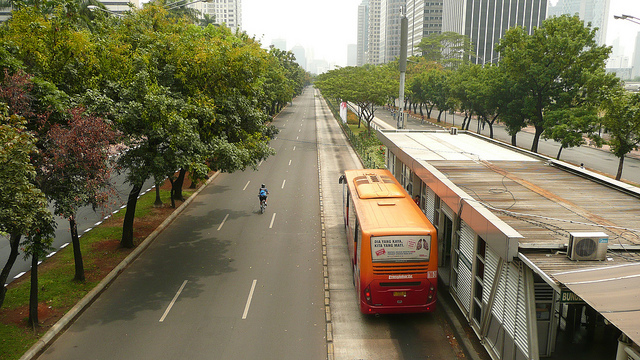<image>What color is this train? There is no train in the image. However, it can be seen as orange or red. What color is this train? This VQA is ambiguous. The train can be either red or orange. 